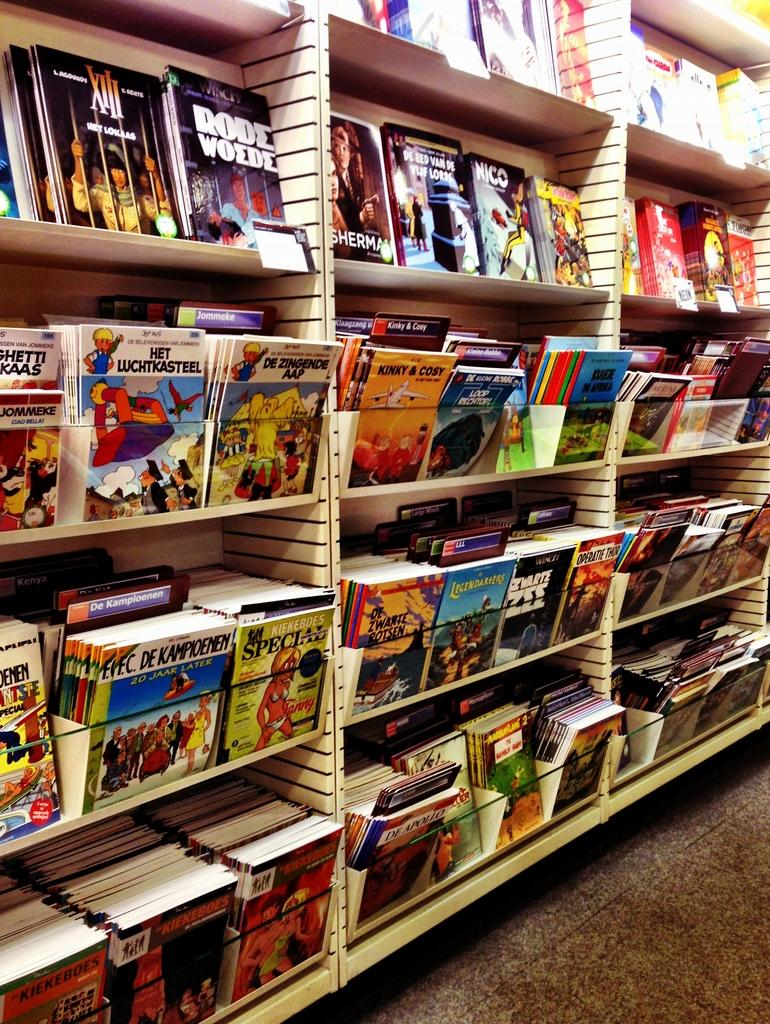What type of furniture is present in the image? There are cabinets in the image. What are the cabinets being used for? The cabinets are being used to store books. Can you see a ship sailing in the background of the image? There is no ship present in the image; it only features cabinets with books. 